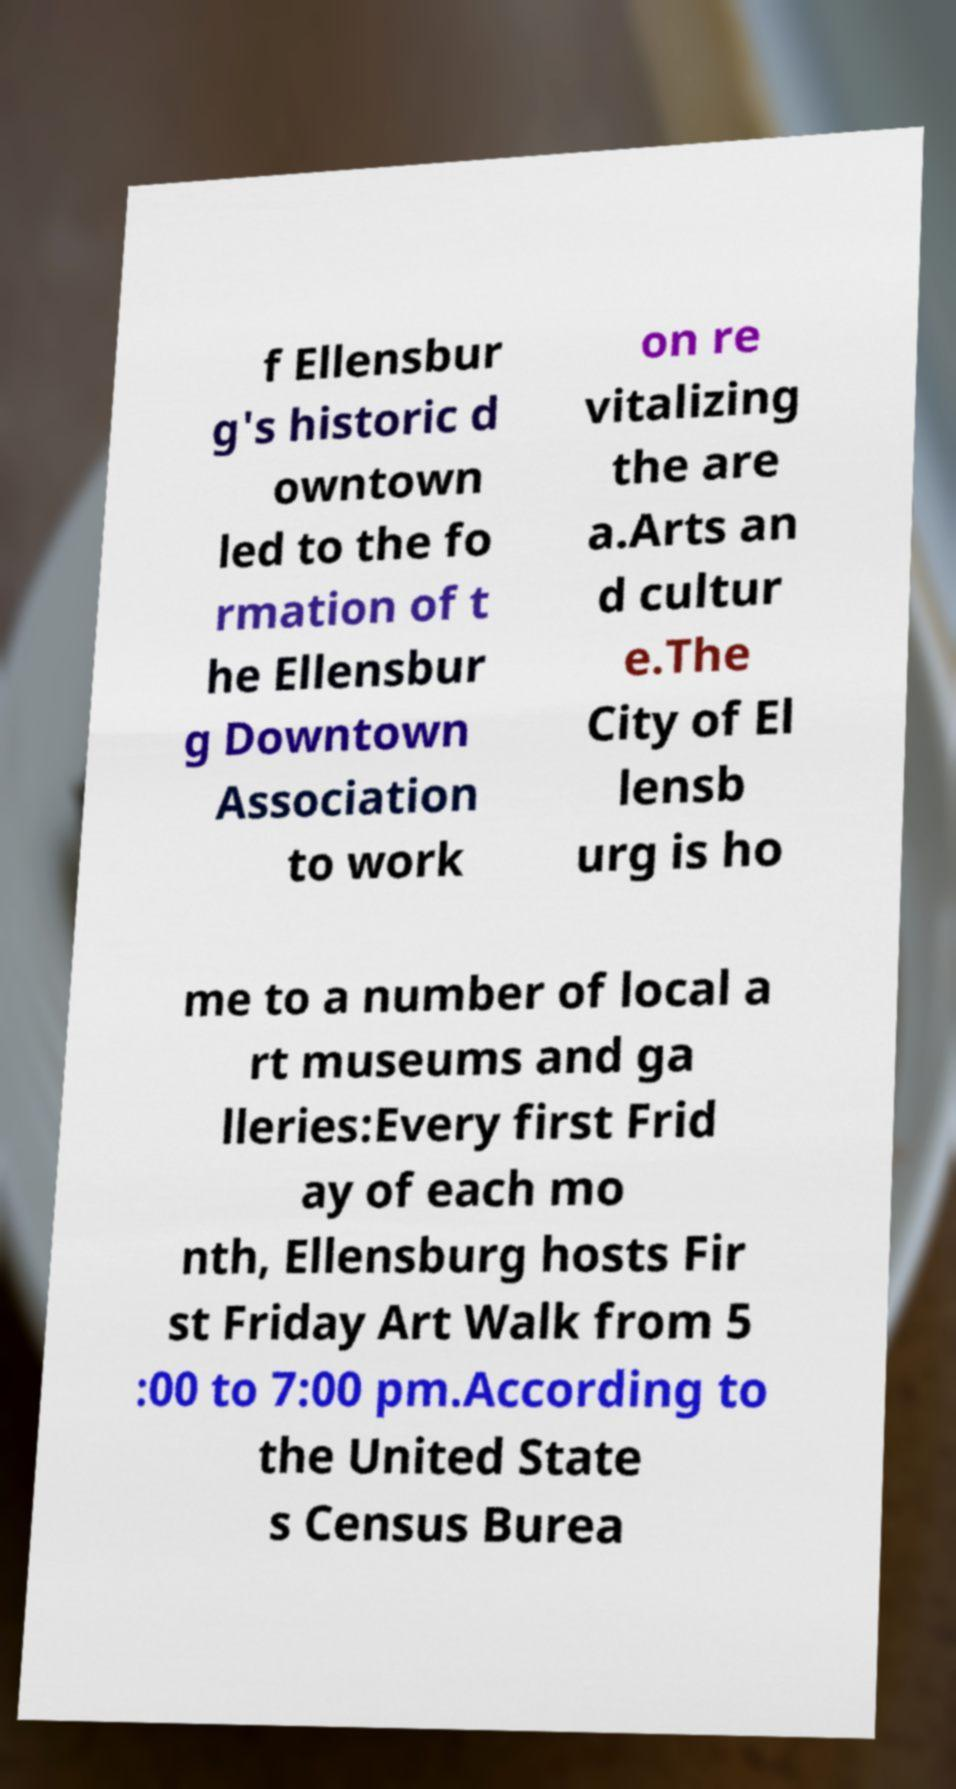For documentation purposes, I need the text within this image transcribed. Could you provide that? f Ellensbur g's historic d owntown led to the fo rmation of t he Ellensbur g Downtown Association to work on re vitalizing the are a.Arts an d cultur e.The City of El lensb urg is ho me to a number of local a rt museums and ga lleries:Every first Frid ay of each mo nth, Ellensburg hosts Fir st Friday Art Walk from 5 :00 to 7:00 pm.According to the United State s Census Burea 